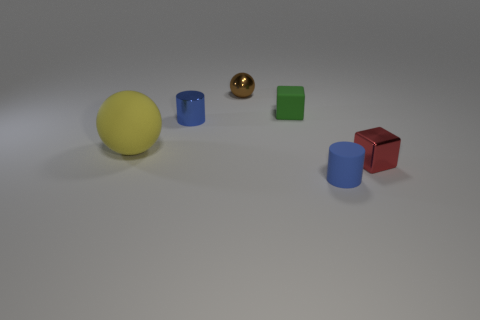Add 3 big purple cylinders. How many objects exist? 9 Subtract 0 cyan cylinders. How many objects are left? 6 Subtract all large things. Subtract all blue rubber cylinders. How many objects are left? 4 Add 4 metal balls. How many metal balls are left? 5 Add 5 tiny blue metal cylinders. How many tiny blue metal cylinders exist? 6 